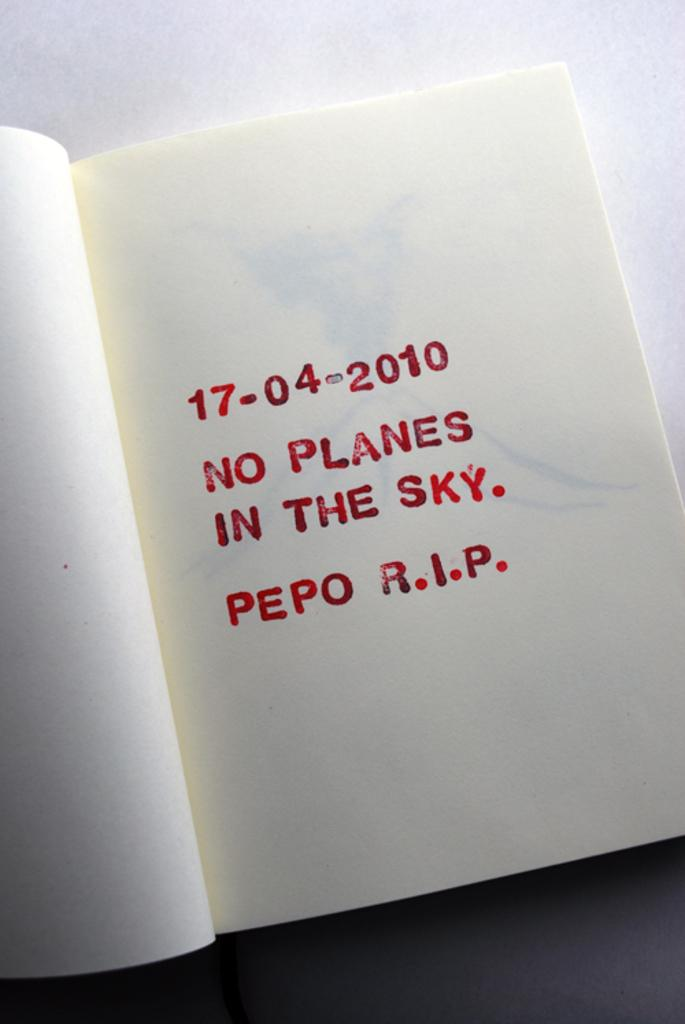<image>
Write a terse but informative summary of the picture. A book is open to a page that says the date 17-04-2010 on it. 